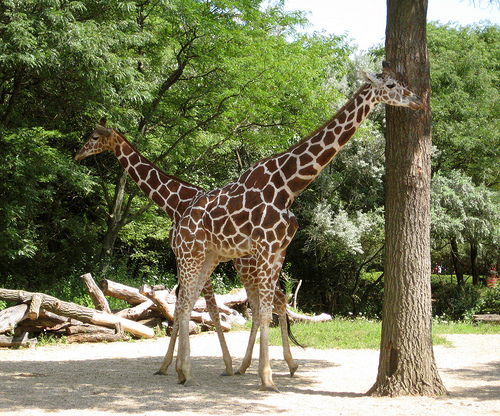<image>
Is the pattern next to the tree? No. The pattern is not positioned next to the tree. They are located in different areas of the scene. Is there a giraffe behind the giraffe? Yes. From this viewpoint, the giraffe is positioned behind the giraffe, with the giraffe partially or fully occluding the giraffe. Where is the giraffe in relation to the giraffe? Is it behind the giraffe? No. The giraffe is not behind the giraffe. From this viewpoint, the giraffe appears to be positioned elsewhere in the scene. 